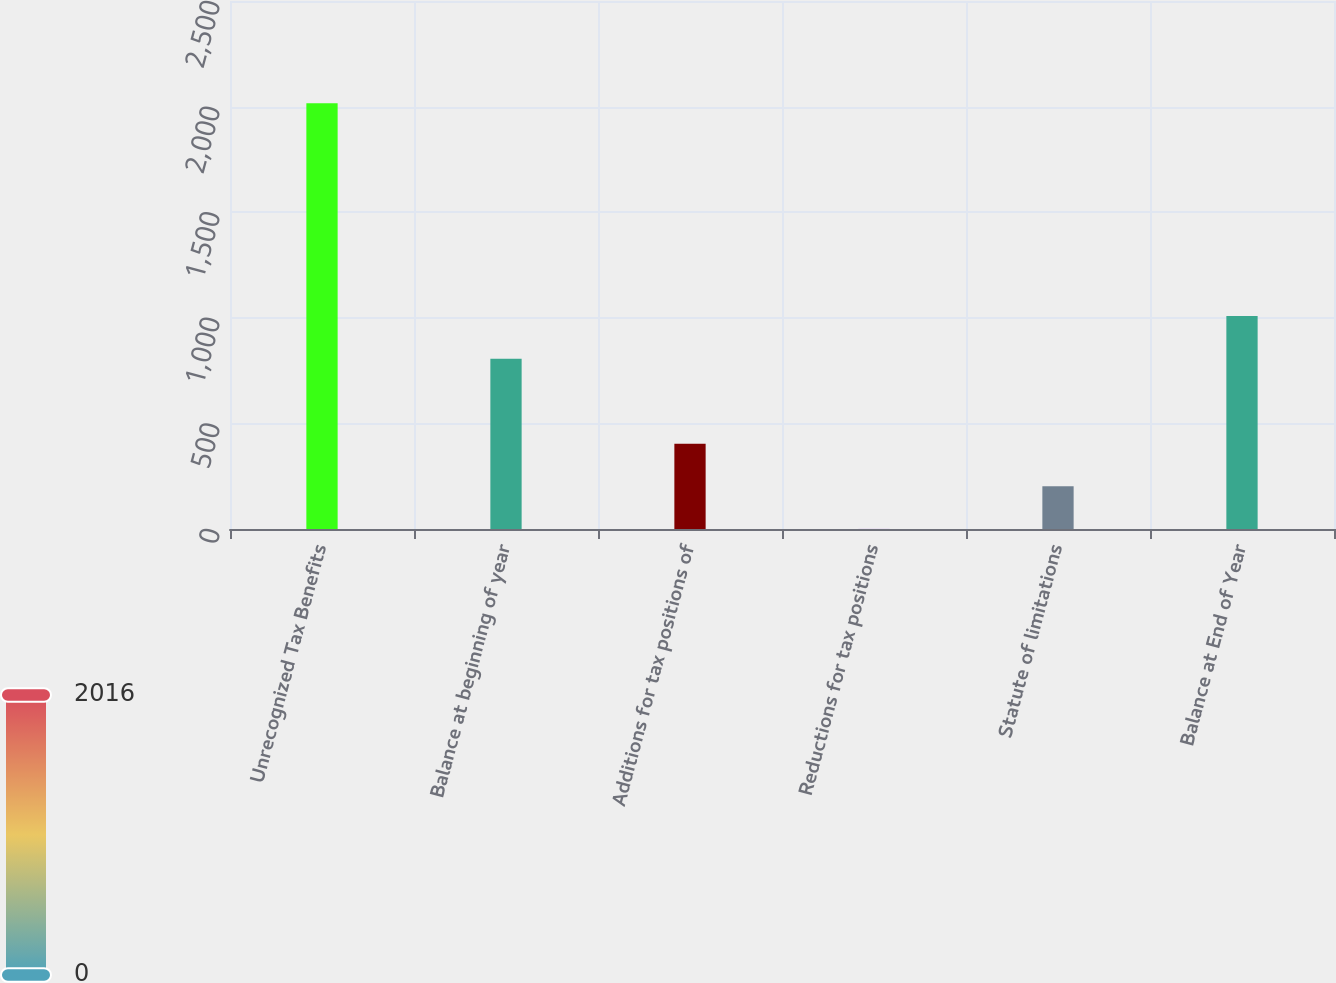Convert chart to OTSL. <chart><loc_0><loc_0><loc_500><loc_500><bar_chart><fcel>Unrecognized Tax Benefits<fcel>Balance at beginning of year<fcel>Additions for tax positions of<fcel>Reductions for tax positions<fcel>Statute of limitations<fcel>Balance at End of Year<nl><fcel>2016<fcel>806.58<fcel>403.44<fcel>0.3<fcel>201.87<fcel>1008.15<nl></chart> 